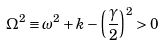<formula> <loc_0><loc_0><loc_500><loc_500>\Omega ^ { 2 } \equiv \omega ^ { 2 } + k - \left ( \frac { \gamma } { 2 } \right ) ^ { 2 } > 0</formula> 